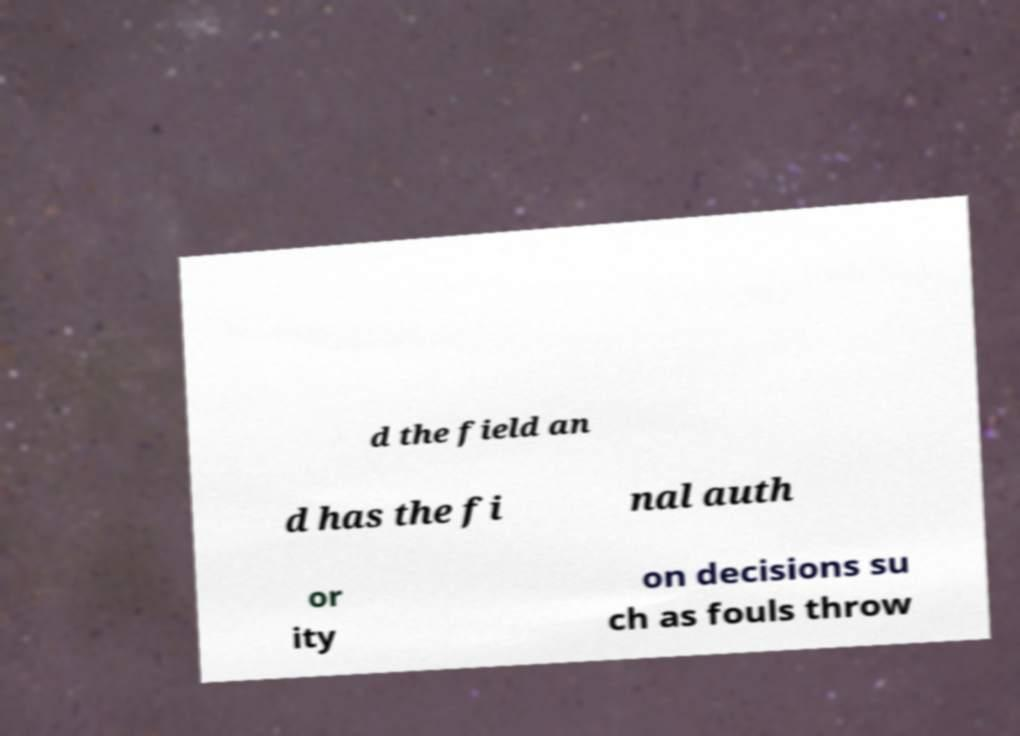Please read and relay the text visible in this image. What does it say? d the field an d has the fi nal auth or ity on decisions su ch as fouls throw 